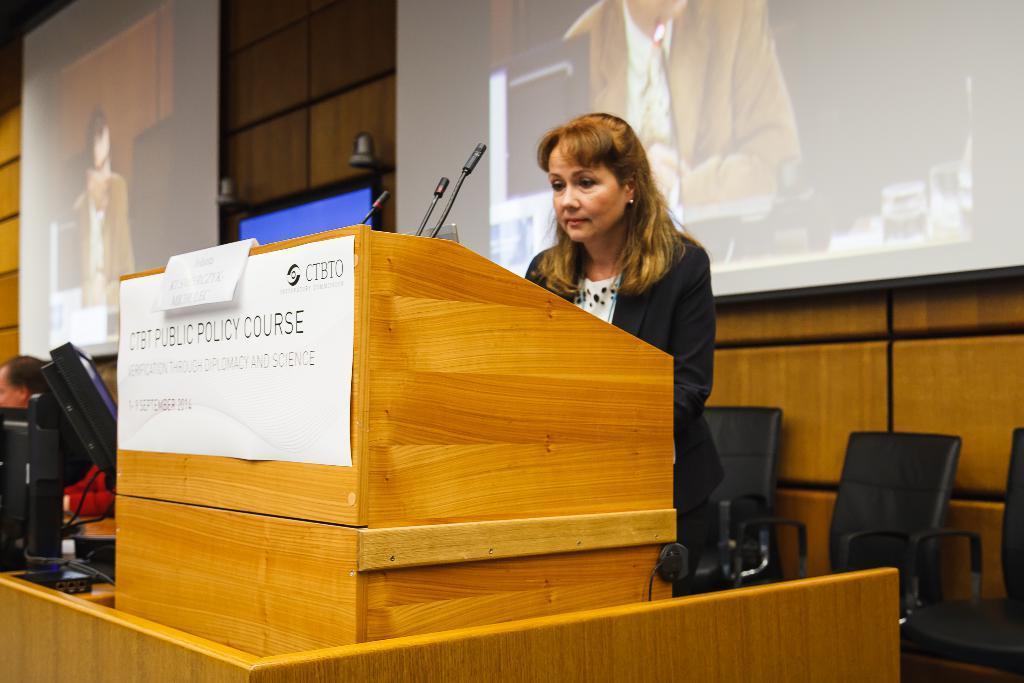Please provide a concise description of this image. This picture is of inside. In the center we can see a woman standing behind the podium and there are microphones attached to the podium. On the left corner we can see the monitor placed on the top of the table. On the right there are some chairs. In the background we can see a wall and two projector screens. 